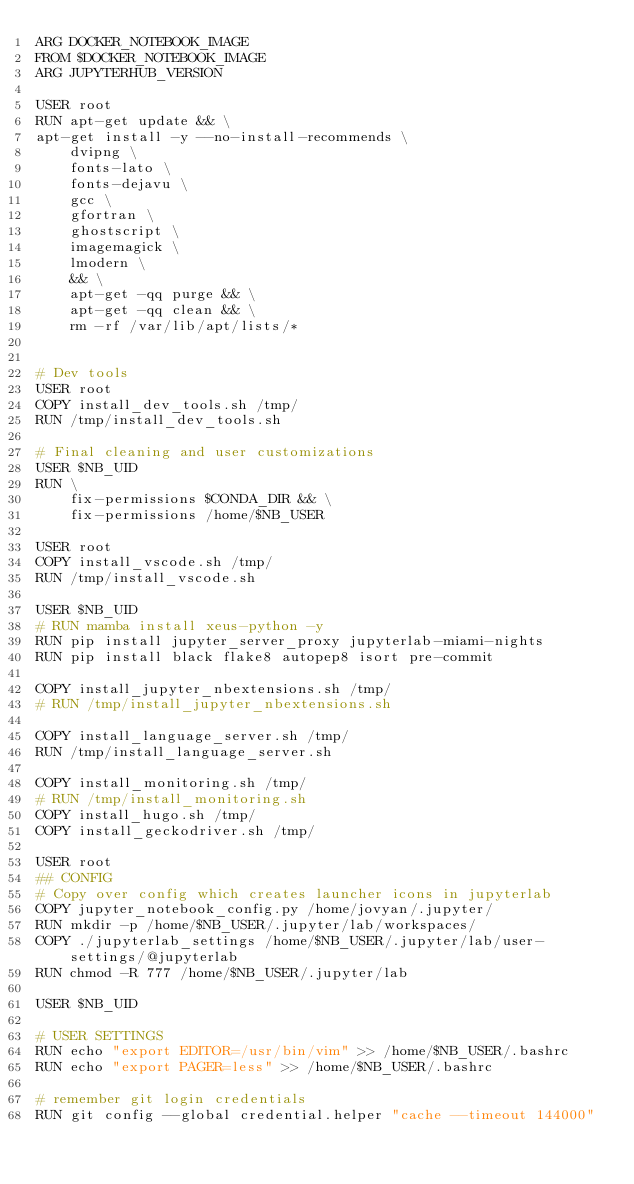Convert code to text. <code><loc_0><loc_0><loc_500><loc_500><_Dockerfile_>ARG DOCKER_NOTEBOOK_IMAGE
FROM $DOCKER_NOTEBOOK_IMAGE
ARG JUPYTERHUB_VERSION

USER root
RUN apt-get update && \
apt-get install -y --no-install-recommends \
	dvipng \
	fonts-lato \
	fonts-dejavu \
	gcc \
	gfortran \
	ghostscript \
	imagemagick \
	lmodern \ 
	&& \
	apt-get -qq purge && \
	apt-get -qq clean && \
	rm -rf /var/lib/apt/lists/*


# Dev tools
USER root
COPY install_dev_tools.sh /tmp/
RUN /tmp/install_dev_tools.sh

# Final cleaning and user customizations
USER $NB_UID
RUN \
    fix-permissions $CONDA_DIR && \
    fix-permissions /home/$NB_USER

USER root
COPY install_vscode.sh /tmp/
RUN /tmp/install_vscode.sh

USER $NB_UID
# RUN mamba install xeus-python -y
RUN pip install jupyter_server_proxy jupyterlab-miami-nights
RUN pip install black flake8 autopep8 isort pre-commit

COPY install_jupyter_nbextensions.sh /tmp/
# RUN /tmp/install_jupyter_nbextensions.sh

COPY install_language_server.sh /tmp/
RUN /tmp/install_language_server.sh

COPY install_monitoring.sh /tmp/
# RUN /tmp/install_monitoring.sh
COPY install_hugo.sh /tmp/
COPY install_geckodriver.sh /tmp/

USER root
## CONFIG
# Copy over config which creates launcher icons in jupyterlab
COPY jupyter_notebook_config.py /home/jovyan/.jupyter/
RUN mkdir -p /home/$NB_USER/.jupyter/lab/workspaces/
COPY ./jupyterlab_settings /home/$NB_USER/.jupyter/lab/user-settings/@jupyterlab
RUN chmod -R 777 /home/$NB_USER/.jupyter/lab

USER $NB_UID

# USER SETTINGS
RUN echo "export EDITOR=/usr/bin/vim" >> /home/$NB_USER/.bashrc
RUN echo "export PAGER=less" >> /home/$NB_USER/.bashrc

# remember git login credentials
RUN git config --global credential.helper "cache --timeout 144000"
</code> 